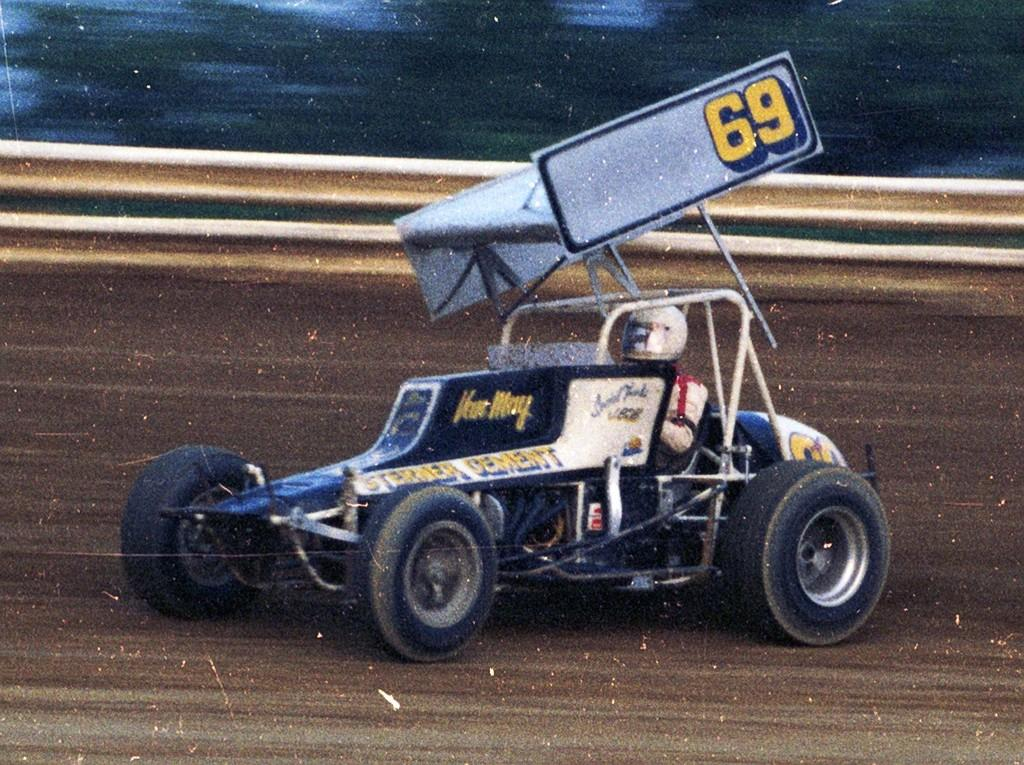<image>
Describe the image concisely. A picture of a go kart displaying the number 69 